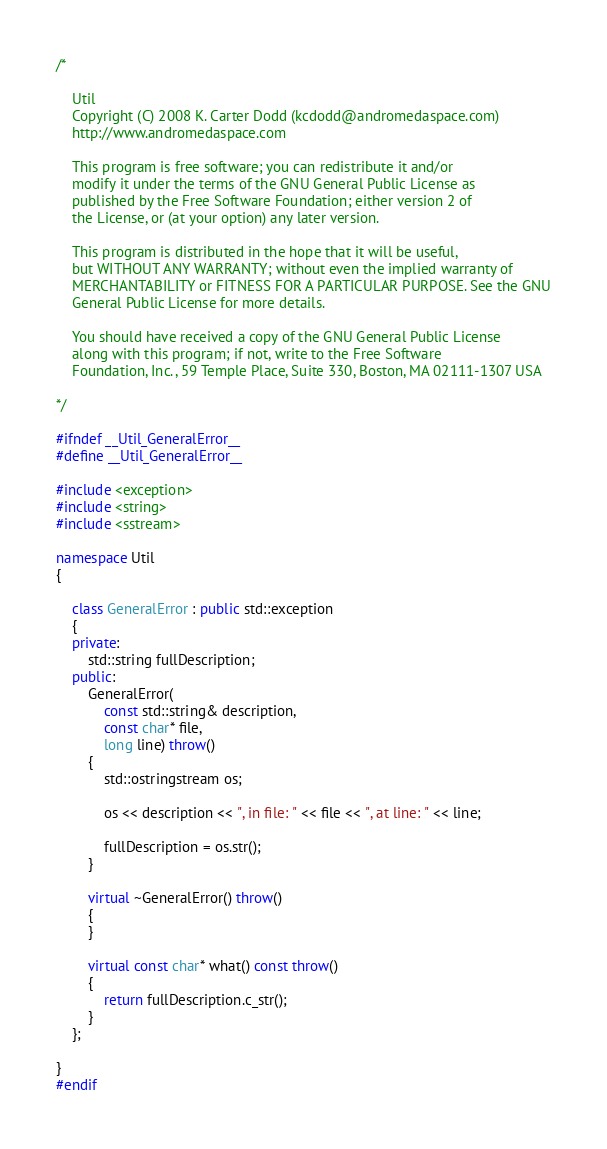<code> <loc_0><loc_0><loc_500><loc_500><_C++_>/*

    Util
    Copyright (C) 2008 K. Carter Dodd (kcdodd@andromedaspace.com)
    http://www.andromedaspace.com

    This program is free software; you can redistribute it and/or
    modify it under the terms of the GNU General Public License as
    published by the Free Software Foundation; either version 2 of
    the License, or (at your option) any later version.

    This program is distributed in the hope that it will be useful,
    but WITHOUT ANY WARRANTY; without even the implied warranty of
    MERCHANTABILITY or FITNESS FOR A PARTICULAR PURPOSE. See the GNU
    General Public License for more details.

    You should have received a copy of the GNU General Public License
    along with this program; if not, write to the Free Software
    Foundation, Inc., 59 Temple Place, Suite 330, Boston, MA 02111-1307 USA

*/

#ifndef __Util_GeneralError__
#define __Util_GeneralError__

#include <exception>
#include <string>
#include <sstream>

namespace Util
{

    class GeneralError : public std::exception
    {
    private:
        std::string fullDescription;
    public:
        GeneralError(
            const std::string& description,
            const char* file,
            long line) throw()
        {
            std::ostringstream os;

            os << description << ", in file: " << file << ", at line: " << line;

            fullDescription = os.str();
        }

        virtual ~GeneralError() throw()
        {
        }

        virtual const char* what() const throw()
        {
            return fullDescription.c_str();
        }
    };

}
#endif
</code> 